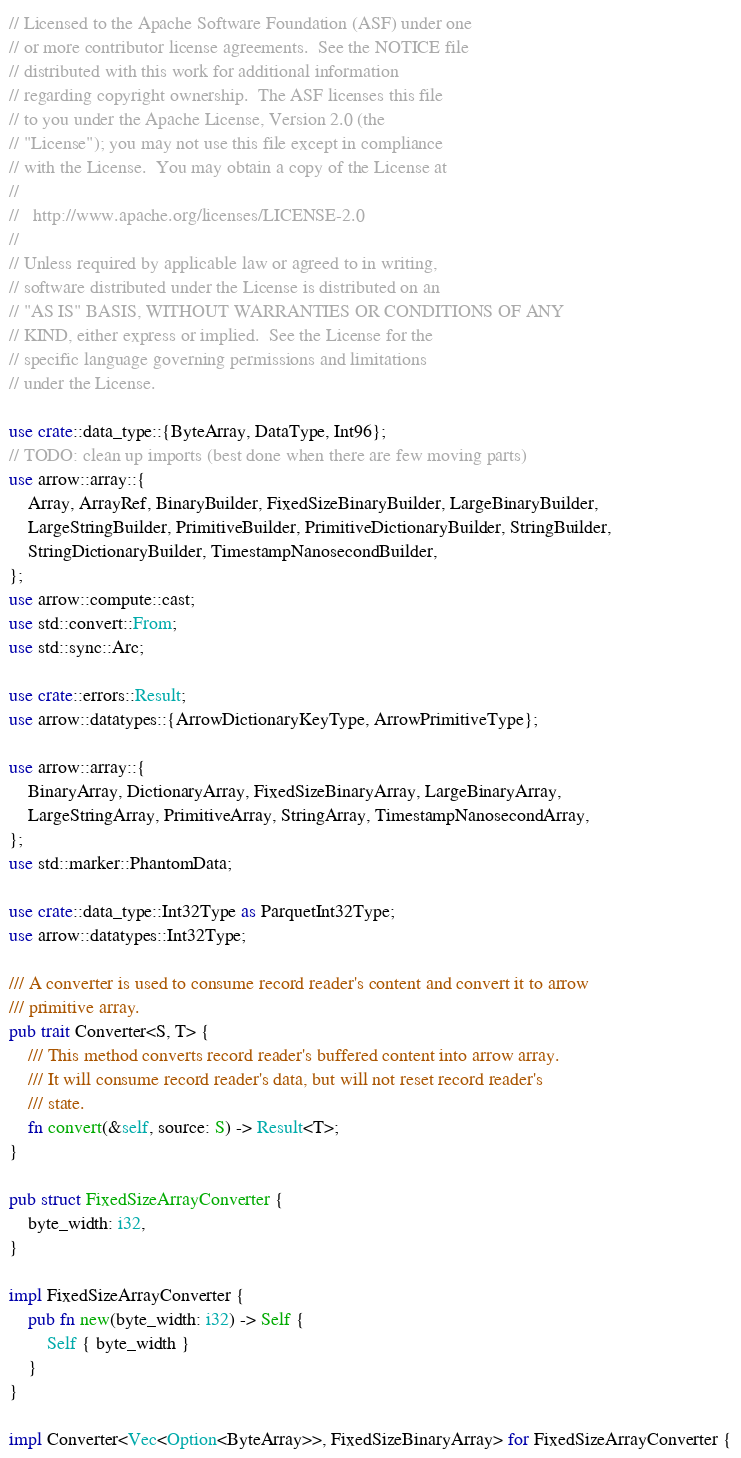Convert code to text. <code><loc_0><loc_0><loc_500><loc_500><_Rust_>// Licensed to the Apache Software Foundation (ASF) under one
// or more contributor license agreements.  See the NOTICE file
// distributed with this work for additional information
// regarding copyright ownership.  The ASF licenses this file
// to you under the Apache License, Version 2.0 (the
// "License"); you may not use this file except in compliance
// with the License.  You may obtain a copy of the License at
//
//   http://www.apache.org/licenses/LICENSE-2.0
//
// Unless required by applicable law or agreed to in writing,
// software distributed under the License is distributed on an
// "AS IS" BASIS, WITHOUT WARRANTIES OR CONDITIONS OF ANY
// KIND, either express or implied.  See the License for the
// specific language governing permissions and limitations
// under the License.

use crate::data_type::{ByteArray, DataType, Int96};
// TODO: clean up imports (best done when there are few moving parts)
use arrow::array::{
    Array, ArrayRef, BinaryBuilder, FixedSizeBinaryBuilder, LargeBinaryBuilder,
    LargeStringBuilder, PrimitiveBuilder, PrimitiveDictionaryBuilder, StringBuilder,
    StringDictionaryBuilder, TimestampNanosecondBuilder,
};
use arrow::compute::cast;
use std::convert::From;
use std::sync::Arc;

use crate::errors::Result;
use arrow::datatypes::{ArrowDictionaryKeyType, ArrowPrimitiveType};

use arrow::array::{
    BinaryArray, DictionaryArray, FixedSizeBinaryArray, LargeBinaryArray,
    LargeStringArray, PrimitiveArray, StringArray, TimestampNanosecondArray,
};
use std::marker::PhantomData;

use crate::data_type::Int32Type as ParquetInt32Type;
use arrow::datatypes::Int32Type;

/// A converter is used to consume record reader's content and convert it to arrow
/// primitive array.
pub trait Converter<S, T> {
    /// This method converts record reader's buffered content into arrow array.
    /// It will consume record reader's data, but will not reset record reader's
    /// state.
    fn convert(&self, source: S) -> Result<T>;
}

pub struct FixedSizeArrayConverter {
    byte_width: i32,
}

impl FixedSizeArrayConverter {
    pub fn new(byte_width: i32) -> Self {
        Self { byte_width }
    }
}

impl Converter<Vec<Option<ByteArray>>, FixedSizeBinaryArray> for FixedSizeArrayConverter {</code> 